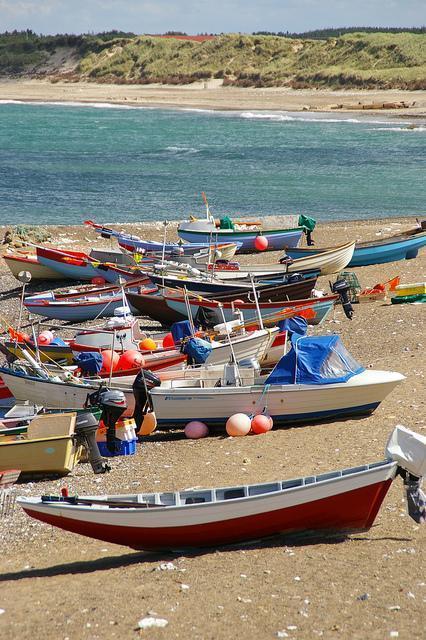How many boats are there?
Give a very brief answer. 10. 